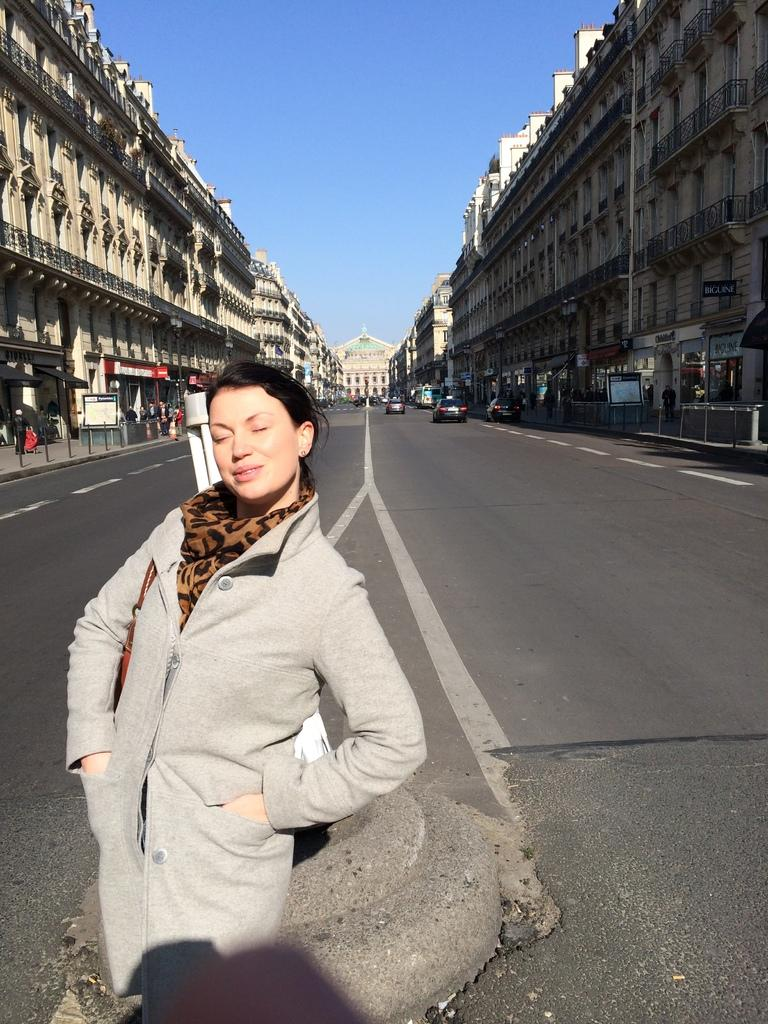Who is the main subject in the image? There is a woman standing in the front of the image. What is the woman doing in the image? The woman is smiling. What can be seen in the background of the image? There are buildings, poles, and cars moving on the road in the background of the image. What type of waste is being disposed of by the woman in the image? There is no waste being disposed of in the image; the woman is simply standing and smiling. 